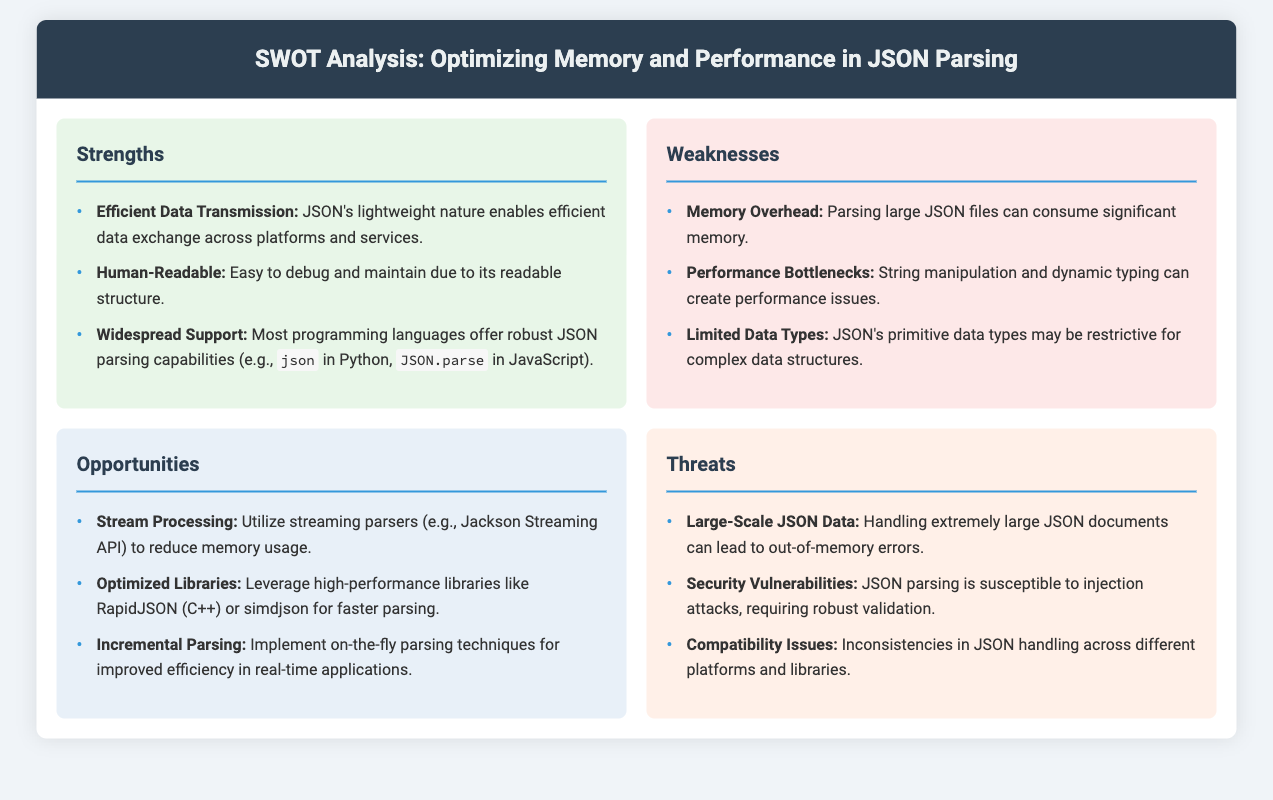What is one strength of JSON? The document states that one strength of JSON is its efficient data transmission due to its lightweight nature.
Answer: Efficient Data Transmission What is one weakness of JSON parsing? The document mentions that one weakness is memory overhead when parsing large JSON files.
Answer: Memory Overhead Name an opportunity for improving JSON parsing. The document lists stream processing as an opportunity to reduce memory usage.
Answer: Stream Processing What is one threat associated with JSON? The document identifies large-scale JSON data as a threat that can lead to out-of-memory errors.
Answer: Large-Scale JSON Data How many weaknesses are mentioned in the document? The document lists three weaknesses pertaining to JSON parsing.
Answer: Three Which programming language offers robust JSON parsing capabilities mentioned in the strengths section? The document refers to Python as one language with solid JSON parsing capabilities.
Answer: Python What does "incremental parsing" refer to in the opportunities section? The document indicates that incremental parsing involves implementing on-the-fly parsing techniques for improved efficiency.
Answer: On-the-fly parsing techniques What is mentioned as a security vulnerability in JSON parsing? The document states that JSON parsing is susceptible to injection attacks.
Answer: Injection attacks Which library is recommended for optimized performance in JSON parsing? The document mentions RapidJSON as a high-performance library for faster parsing.
Answer: RapidJSON 